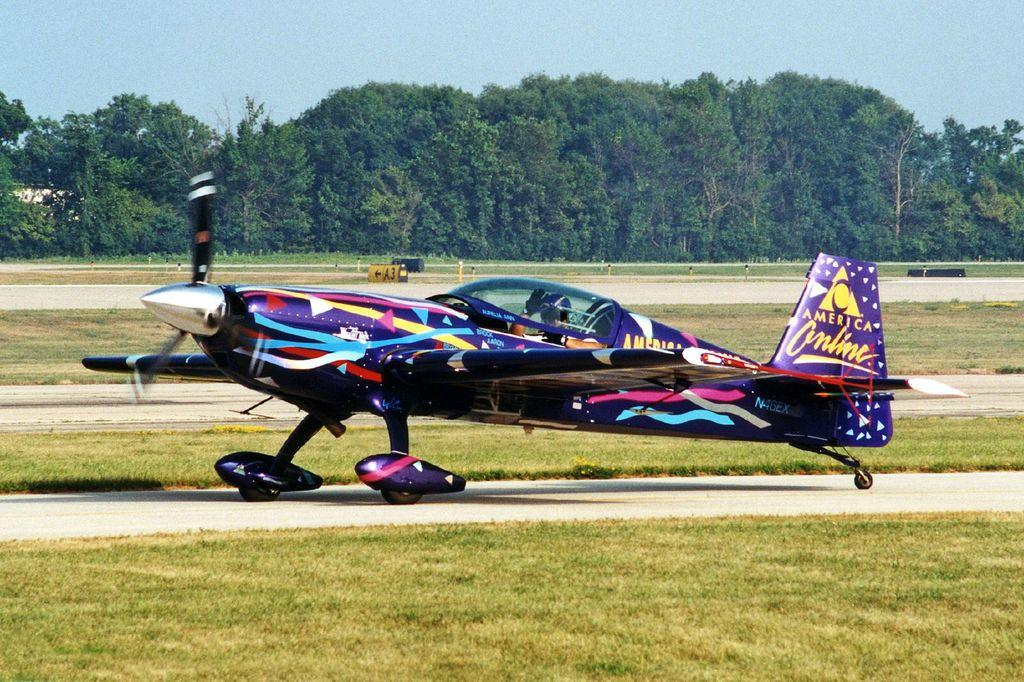<image>
Summarize the visual content of the image. A colorful plane with an America Online logo on the tail. 